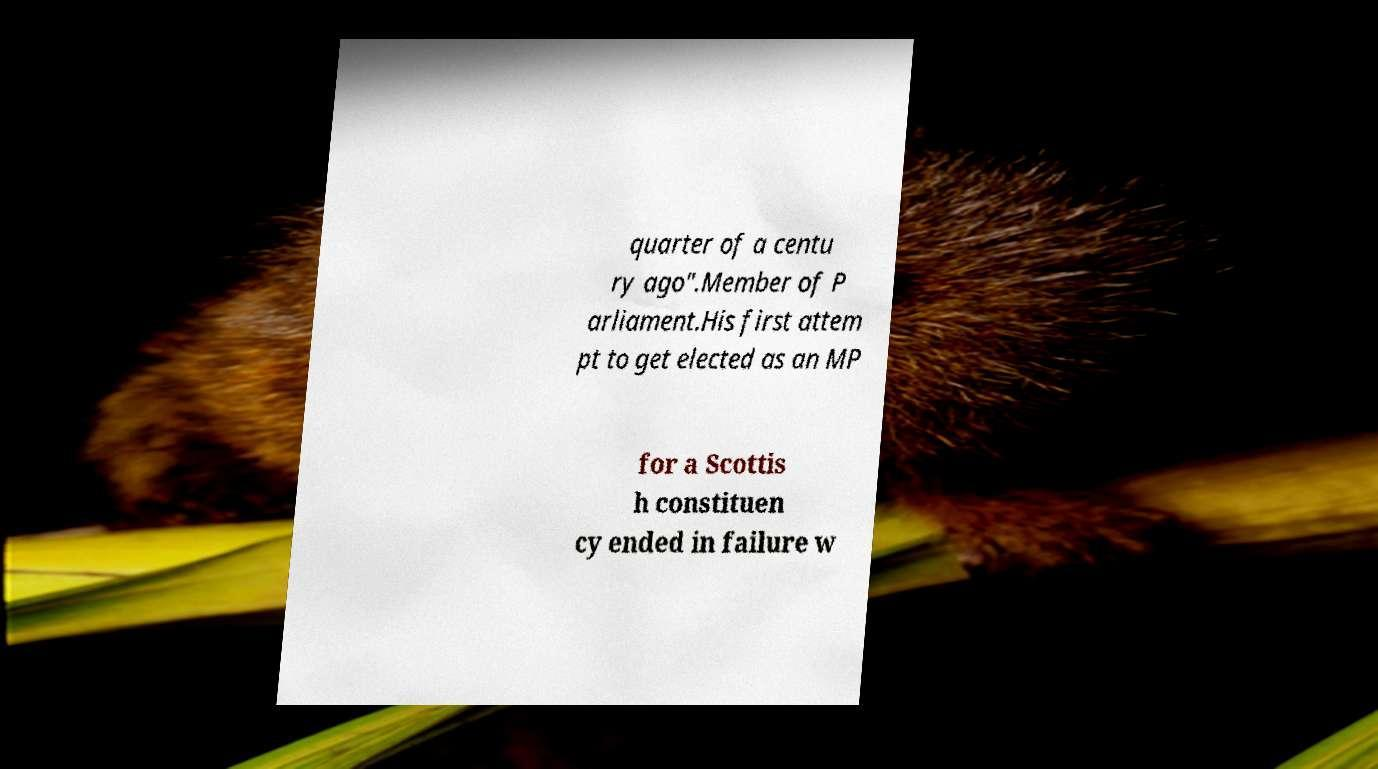Please identify and transcribe the text found in this image. quarter of a centu ry ago".Member of P arliament.His first attem pt to get elected as an MP for a Scottis h constituen cy ended in failure w 